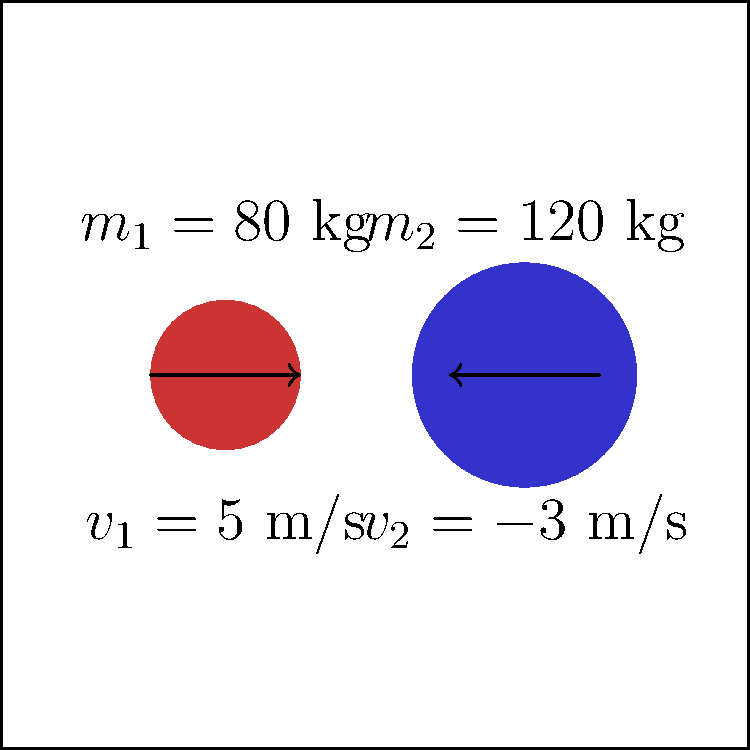During a basketball game, you (mass $m_1 = 80$ kg) are running towards the basket at $5$ m/s when you collide with a tight end (mass $m_2 = 120$ kg) moving in the opposite direction at $3$ m/s. Assuming a perfectly inelastic collision, what is the velocity of the combined players immediately after the collision? To solve this problem, we'll use the principle of conservation of momentum. In a perfectly inelastic collision, the objects stick together after the collision and move with the same velocity.

Step 1: Calculate the initial momentum of each player.
Your momentum: $p_1 = m_1v_1 = 80 \text{ kg} \times 5 \text{ m/s} = 400 \text{ kg}\cdot\text{m/s}$
Tight end's momentum: $p_2 = m_2v_2 = 120 \text{ kg} \times (-3 \text{ m/s}) = -360 \text{ kg}\cdot\text{m/s}$

Step 2: Calculate the total initial momentum.
$p_{total} = p_1 + p_2 = 400 \text{ kg}\cdot\text{m/s} + (-360 \text{ kg}\cdot\text{m/s}) = 40 \text{ kg}\cdot\text{m/s}$

Step 3: Use the conservation of momentum principle. The total momentum before the collision equals the total momentum after the collision.
$(m_1 + m_2)v_f = p_{total}$

Step 4: Solve for the final velocity $v_f$.
$v_f = \frac{p_{total}}{m_1 + m_2} = \frac{40 \text{ kg}\cdot\text{m/s}}{80 \text{ kg} + 120 \text{ kg}} = \frac{40 \text{ kg}\cdot\text{m/s}}{200 \text{ kg}} = 0.2 \text{ m/s}$

Therefore, immediately after the collision, both players will move together at a velocity of 0.2 m/s in the direction you were initially moving.
Answer: 0.2 m/s 